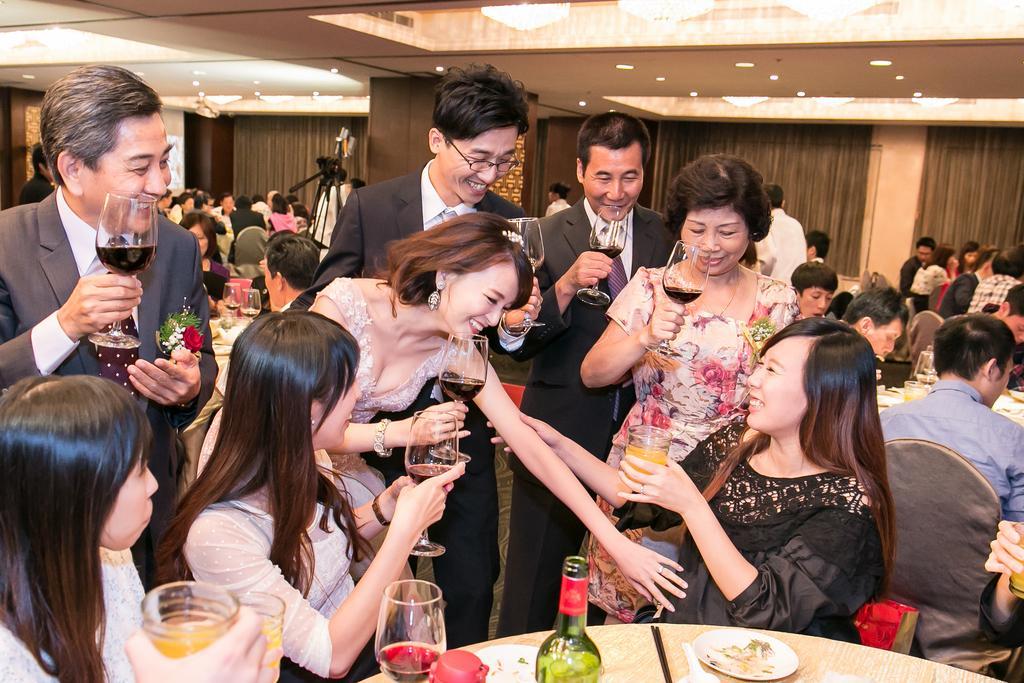Could you give a brief overview of what you see in this image? Here we can see a group of people sitting and some of them are standing the people who are standing having classes of wines in their hands and as well as the people who are sitting also having glasses in their hands and all of them are laughing there is a bottle placed on the table in front of them 